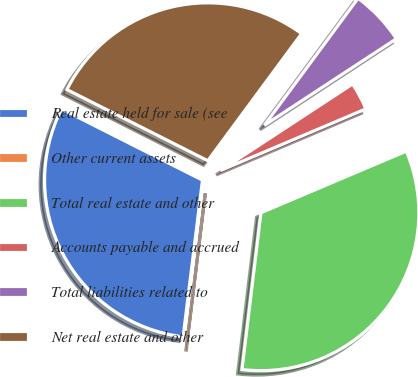<chart> <loc_0><loc_0><loc_500><loc_500><pie_chart><fcel>Real estate held for sale (see<fcel>Other current assets<fcel>Total real estate and other<fcel>Accounts payable and accrued<fcel>Total liabilities related to<fcel>Net real estate and other<nl><fcel>30.49%<fcel>0.04%<fcel>33.3%<fcel>2.85%<fcel>5.65%<fcel>27.68%<nl></chart> 